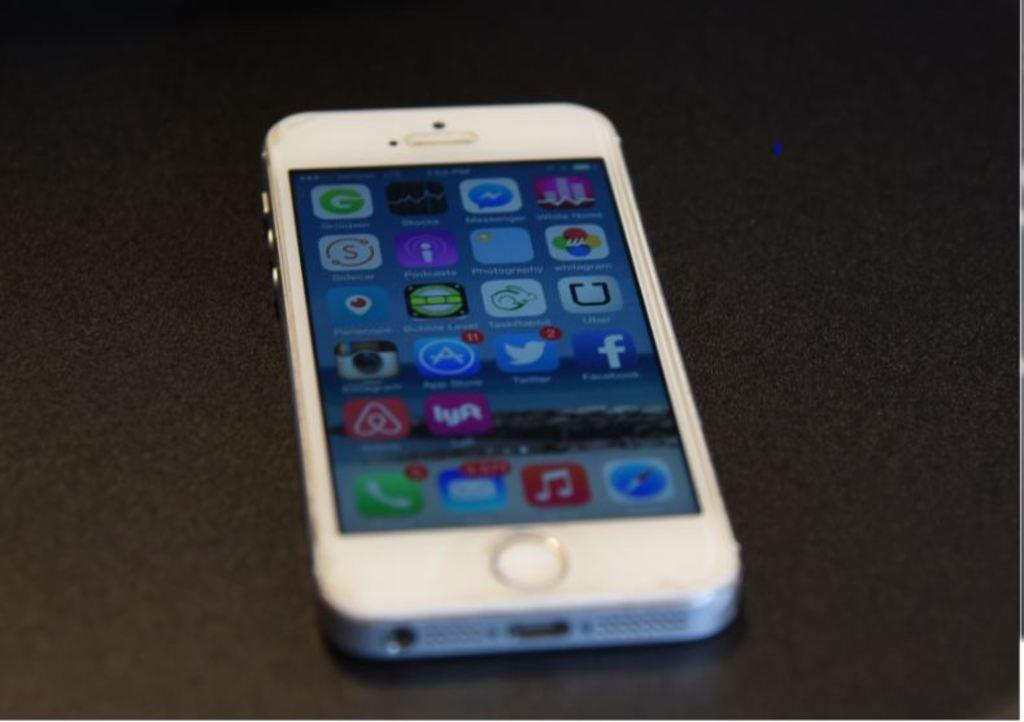<image>
Summarize the visual content of the image. A white phone displays its many apps such as facebook and twitter. 